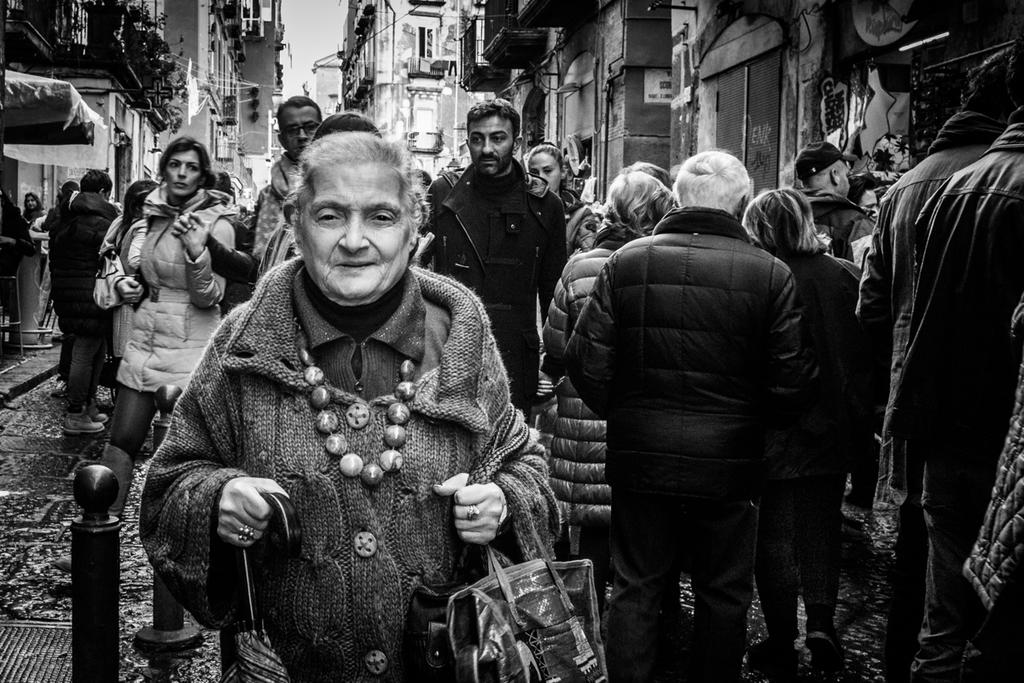How many people are in the image? There is a group of people in the image. What else can be seen in the image besides the people? There are buildings and the sky visible in the image. Can you describe the person holding an umbrella in the image? Yes, there is a person holding an umbrella in the image. What type of grass is growing on the person holding the umbrella in the image? There is no grass present on the person holding the umbrella in the image. 